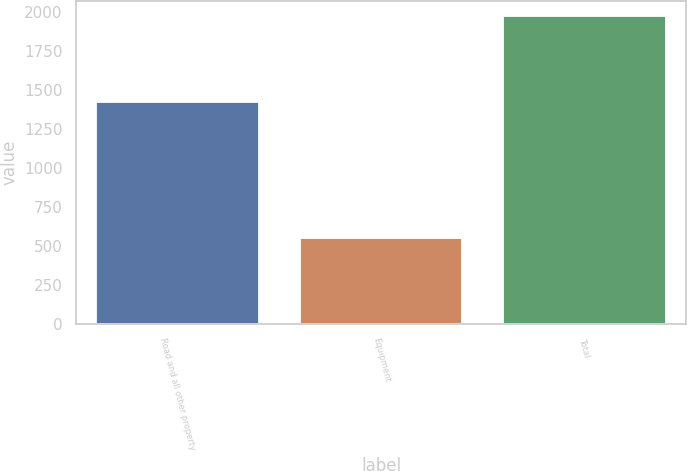Convert chart to OTSL. <chart><loc_0><loc_0><loc_500><loc_500><bar_chart><fcel>Road and all other property<fcel>Equipment<fcel>Total<nl><fcel>1421<fcel>550<fcel>1971<nl></chart> 